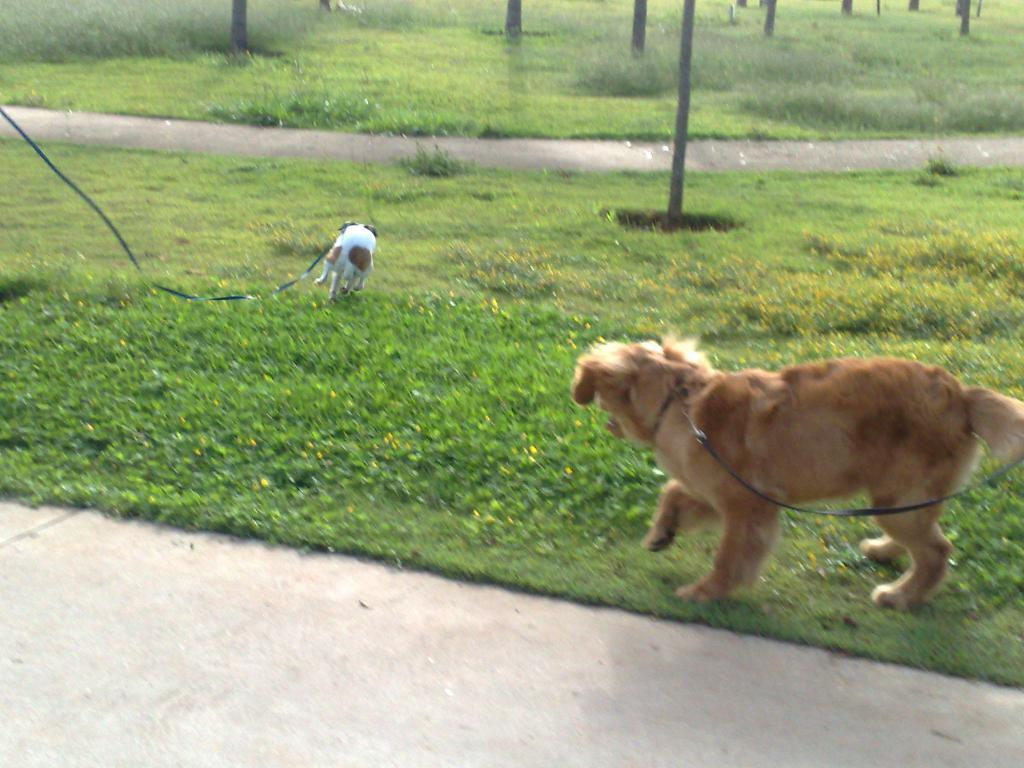What animals are present in the image? There are dogs in the image. Where are the dogs located? The dogs are on the grass. How are the dogs secured in the image? The dogs are tied with belts. What can be seen in the background of the image? There are plants in the background of the image. Where is the woman selling fruits in the market in the image? There is no woman selling fruits in the market in the image; it features dogs on the grass. What type of basin is being used by the dogs in the image? There is no basin present in the image; the dogs are tied with belts. 